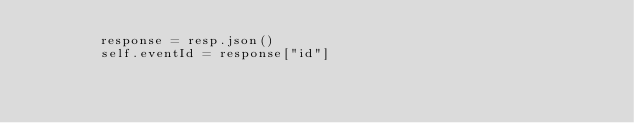<code> <loc_0><loc_0><loc_500><loc_500><_Python_>        response = resp.json()
        self.eventId = response["id"]
</code> 